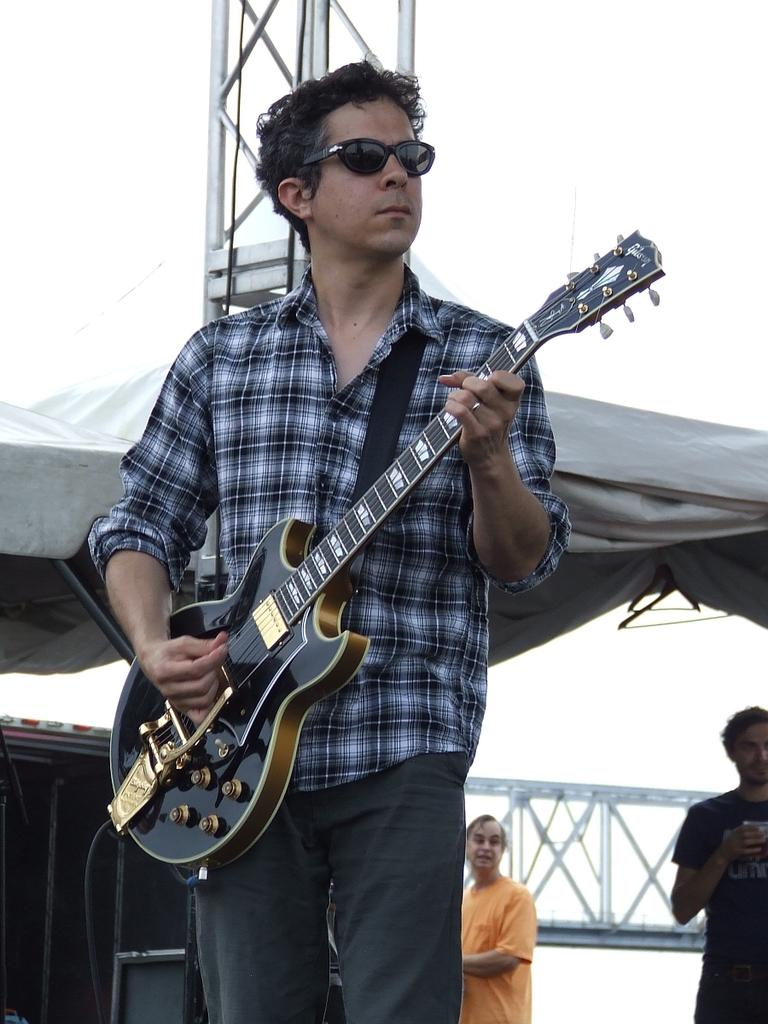What is the man in the image holding? The man is holding a guitar. What can be seen in the background of the image? There is a tent and two men standing in the background of the image. What type of beast can be seen roaming around in the image? There is no beast present in the image. What season is it in the image, considering the presence of the tent? The presence of a tent does not necessarily indicate a specific season, as tents can be used in various weather conditions. 